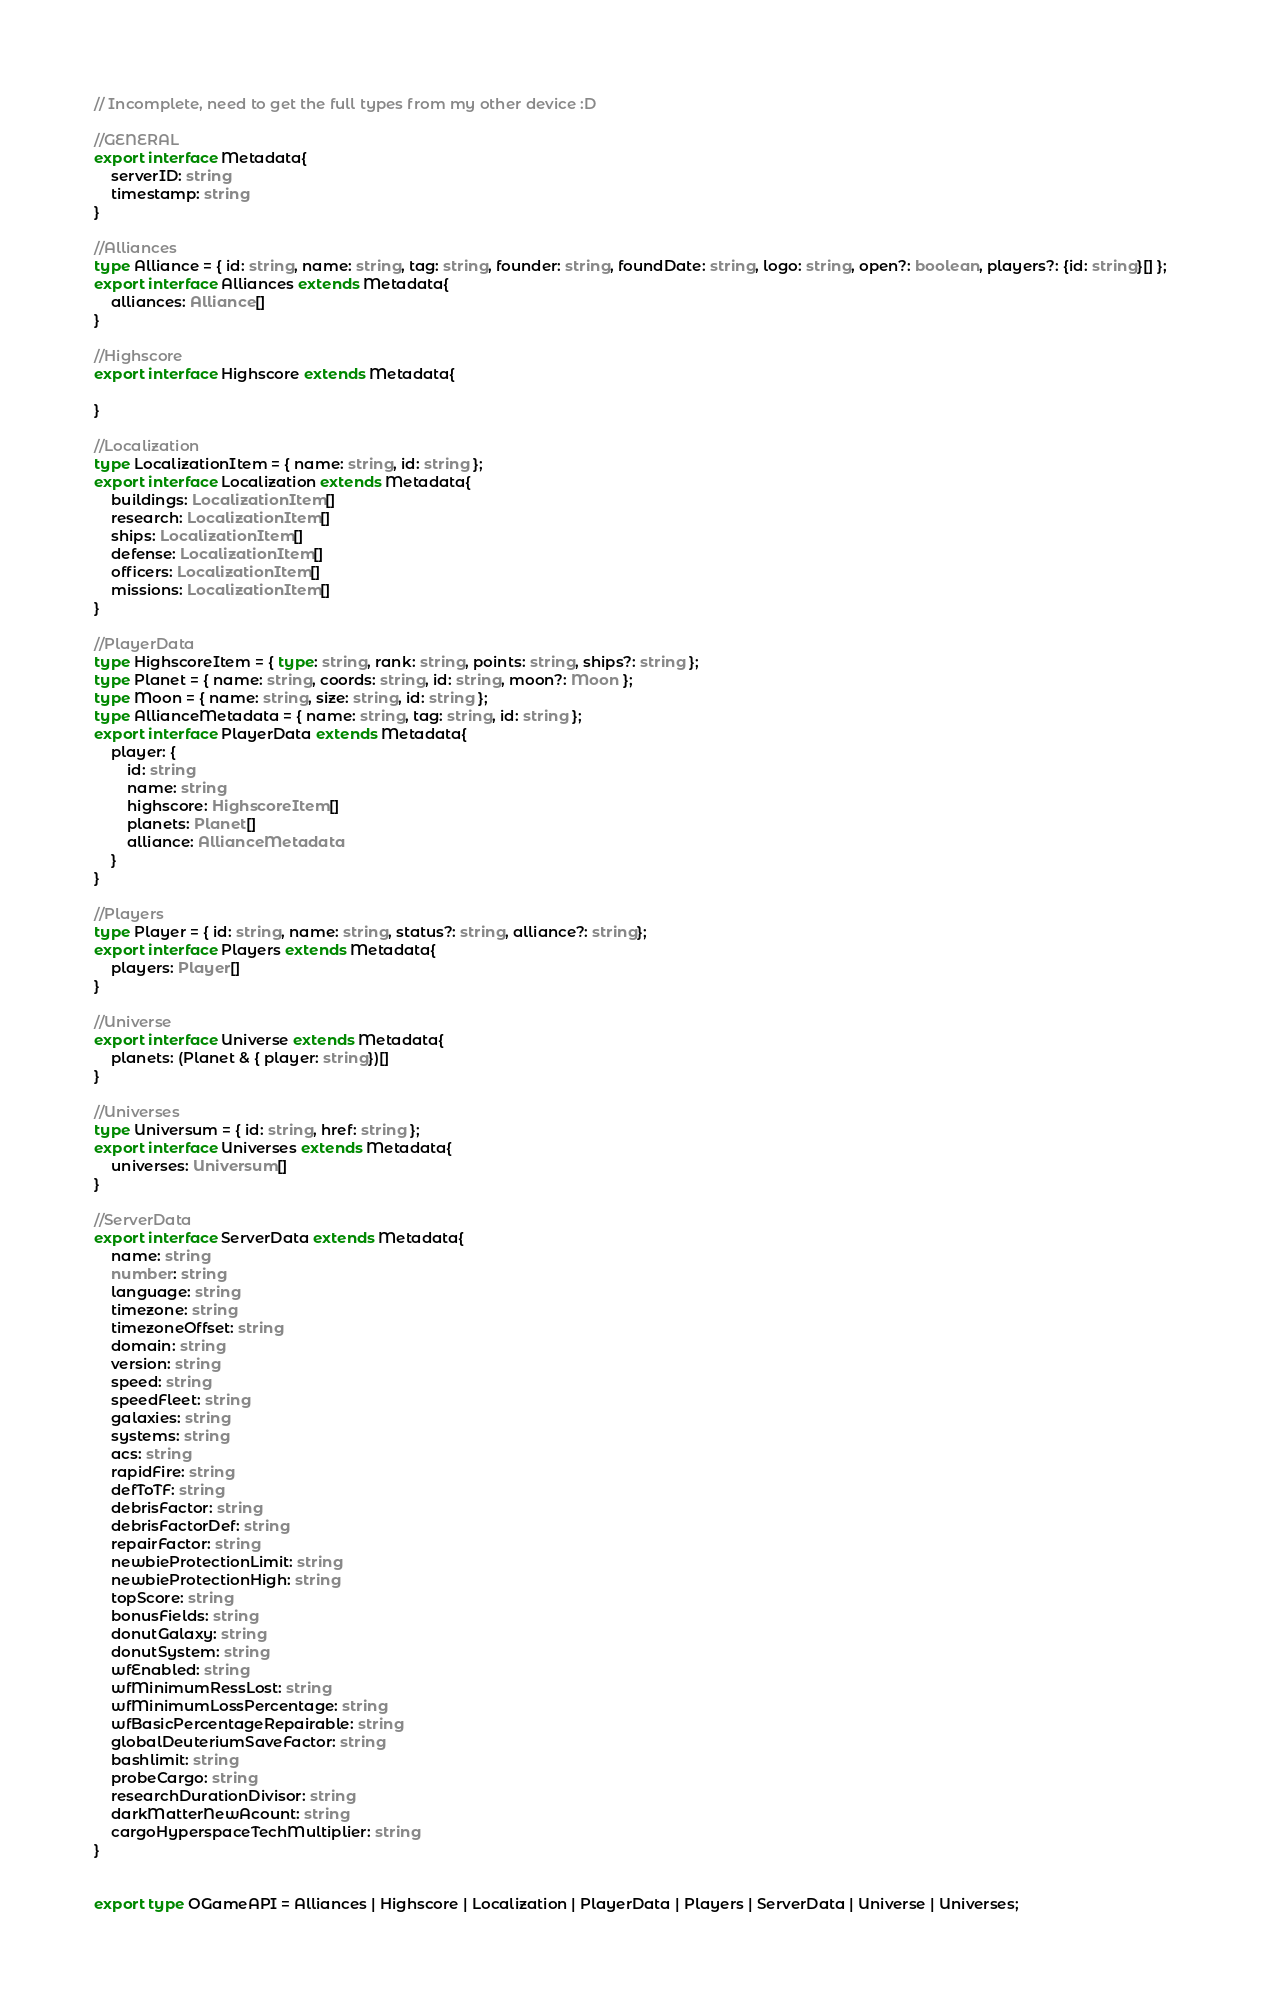Convert code to text. <code><loc_0><loc_0><loc_500><loc_500><_TypeScript_>// Incomplete, need to get the full types from my other device :D

//GENERAL
export interface Metadata{
    serverID: string
    timestamp: string
}

//Alliances
type Alliance = { id: string, name: string, tag: string, founder: string, foundDate: string, logo: string, open?: boolean, players?: {id: string}[] };
export interface Alliances extends Metadata{
    alliances: Alliance[]
}

//Highscore
export interface Highscore extends Metadata{

}

//Localization
type LocalizationItem = { name: string, id: string };
export interface Localization extends Metadata{
    buildings: LocalizationItem[]
    research: LocalizationItem[]
    ships: LocalizationItem[]
    defense: LocalizationItem[]
    officers: LocalizationItem[]
    missions: LocalizationItem[]
}

//PlayerData
type HighscoreItem = { type: string, rank: string, points: string, ships?: string };
type Planet = { name: string, coords: string, id: string, moon?: Moon };
type Moon = { name: string, size: string, id: string };
type AllianceMetadata = { name: string, tag: string, id: string };
export interface PlayerData extends Metadata{
    player: {
        id: string
        name: string
        highscore: HighscoreItem[]
        planets: Planet[]
        alliance: AllianceMetadata
    }
}

//Players
type Player = { id: string, name: string, status?: string, alliance?: string};
export interface Players extends Metadata{
    players: Player[]
}

//Universe
export interface Universe extends Metadata{
    planets: (Planet & { player: string})[]
}

//Universes
type Universum = { id: string, href: string };
export interface Universes extends Metadata{
    universes: Universum[]
}

//ServerData
export interface ServerData extends Metadata{
    name: string
    number: string
    language: string
    timezone: string
    timezoneOffset: string
    domain: string
    version: string
    speed: string
    speedFleet: string
    galaxies: string
    systems: string
    acs: string
    rapidFire: string
    defToTF: string
    debrisFactor: string
    debrisFactorDef: string
    repairFactor: string
    newbieProtectionLimit: string
    newbieProtectionHigh: string
    topScore: string
    bonusFields: string
    donutGalaxy: string
    donutSystem: string
    wfEnabled: string
    wfMinimumRessLost: string
    wfMinimumLossPercentage: string
    wfBasicPercentageRepairable: string
    globalDeuteriumSaveFactor: string
    bashlimit: string
    probeCargo: string
    researchDurationDivisor: string
    darkMatterNewAcount: string
    cargoHyperspaceTechMultiplier: string
}


export type OGameAPI = Alliances | Highscore | Localization | PlayerData | Players | ServerData | Universe | Universes;</code> 